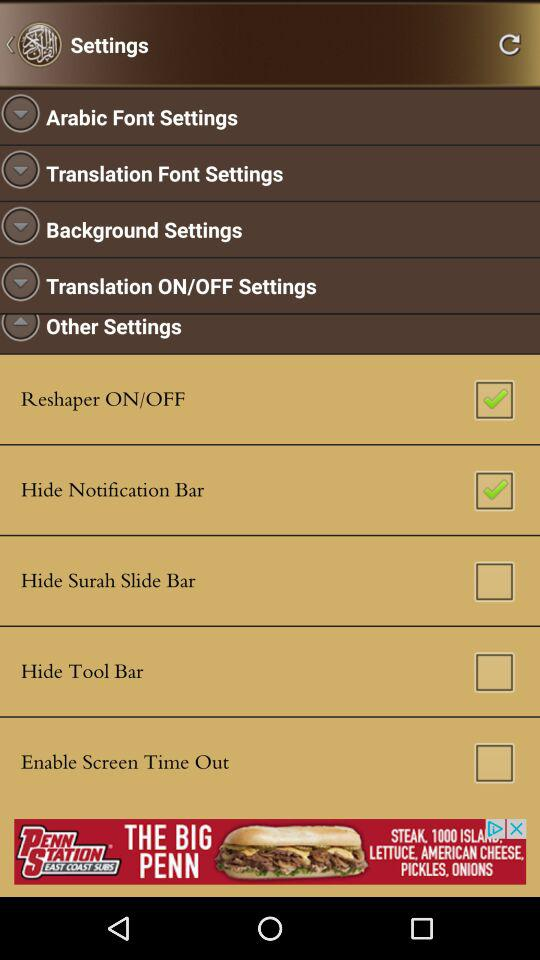What is the checkbox status of "Hide Surah Slide Bar"? The status is "off". 